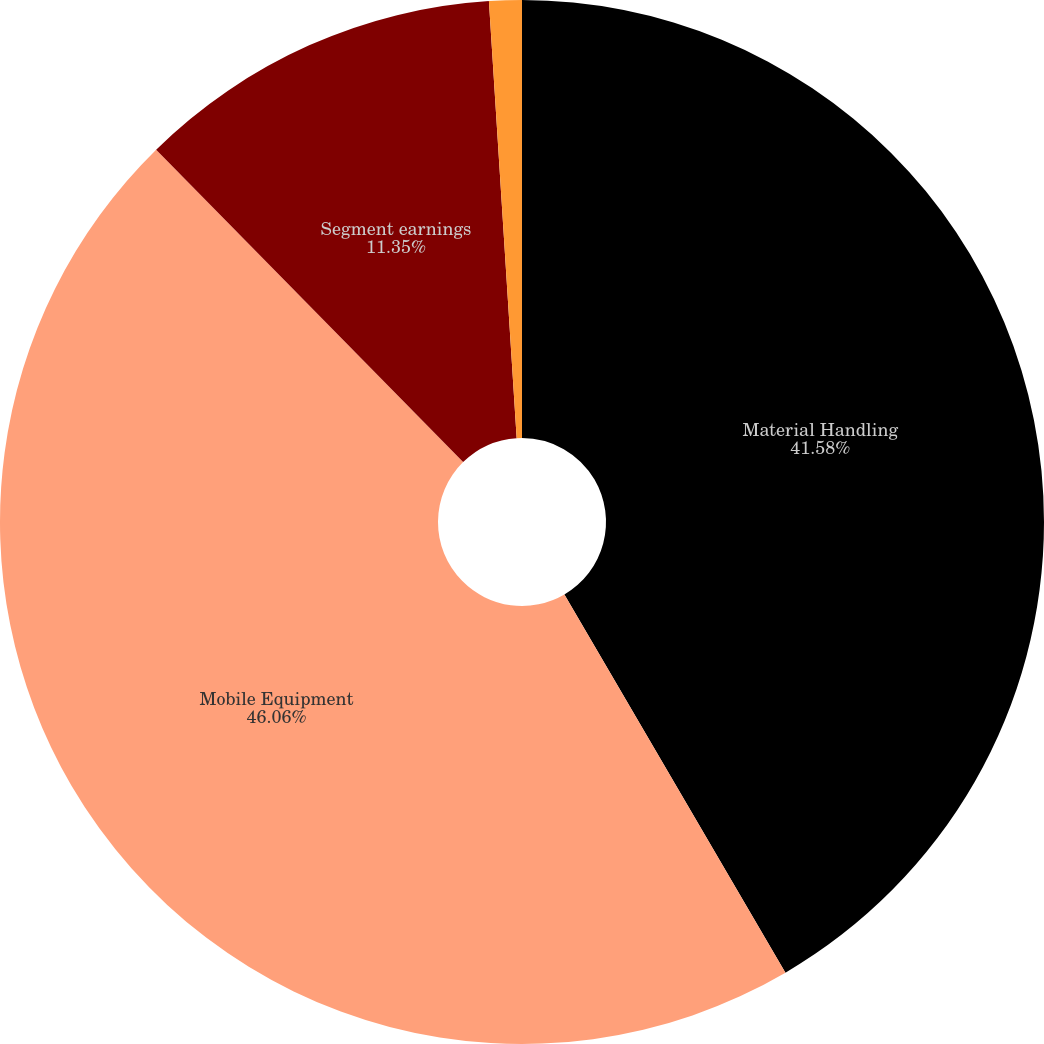Convert chart. <chart><loc_0><loc_0><loc_500><loc_500><pie_chart><fcel>Material Handling<fcel>Mobile Equipment<fcel>Segment earnings<fcel>Acquisition related<nl><fcel>41.58%<fcel>46.06%<fcel>11.35%<fcel>1.01%<nl></chart> 